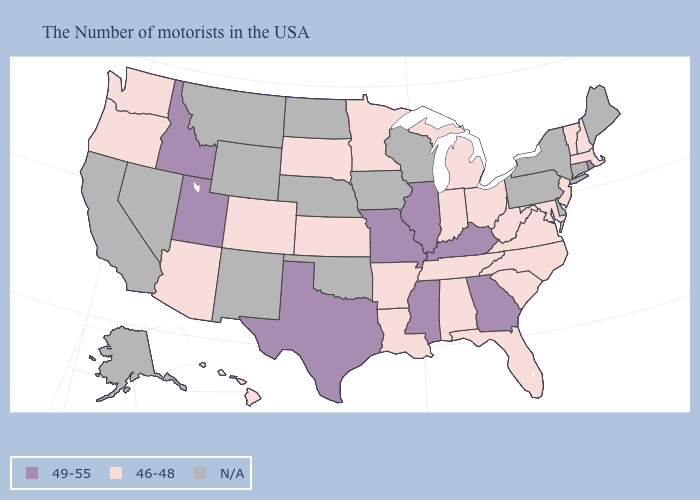Among the states that border South Dakota , which have the highest value?
Quick response, please. Minnesota. Name the states that have a value in the range 46-48?
Quick response, please. Massachusetts, New Hampshire, Vermont, New Jersey, Maryland, Virginia, North Carolina, South Carolina, West Virginia, Ohio, Florida, Michigan, Indiana, Alabama, Tennessee, Louisiana, Arkansas, Minnesota, Kansas, South Dakota, Colorado, Arizona, Washington, Oregon, Hawaii. Name the states that have a value in the range 46-48?
Give a very brief answer. Massachusetts, New Hampshire, Vermont, New Jersey, Maryland, Virginia, North Carolina, South Carolina, West Virginia, Ohio, Florida, Michigan, Indiana, Alabama, Tennessee, Louisiana, Arkansas, Minnesota, Kansas, South Dakota, Colorado, Arizona, Washington, Oregon, Hawaii. What is the value of North Dakota?
Quick response, please. N/A. What is the lowest value in the South?
Answer briefly. 46-48. Which states have the lowest value in the USA?
Give a very brief answer. Massachusetts, New Hampshire, Vermont, New Jersey, Maryland, Virginia, North Carolina, South Carolina, West Virginia, Ohio, Florida, Michigan, Indiana, Alabama, Tennessee, Louisiana, Arkansas, Minnesota, Kansas, South Dakota, Colorado, Arizona, Washington, Oregon, Hawaii. Among the states that border Idaho , does Utah have the lowest value?
Answer briefly. No. What is the lowest value in the USA?
Short answer required. 46-48. Name the states that have a value in the range 49-55?
Short answer required. Rhode Island, Georgia, Kentucky, Illinois, Mississippi, Missouri, Texas, Utah, Idaho. Name the states that have a value in the range N/A?
Keep it brief. Maine, Connecticut, New York, Delaware, Pennsylvania, Wisconsin, Iowa, Nebraska, Oklahoma, North Dakota, Wyoming, New Mexico, Montana, Nevada, California, Alaska. What is the value of New Jersey?
Quick response, please. 46-48. What is the highest value in the MidWest ?
Be succinct. 49-55. Does Arizona have the lowest value in the West?
Quick response, please. Yes. 